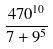<formula> <loc_0><loc_0><loc_500><loc_500>\frac { 4 7 0 ^ { 1 0 } } { 7 + 9 ^ { 5 } }</formula> 